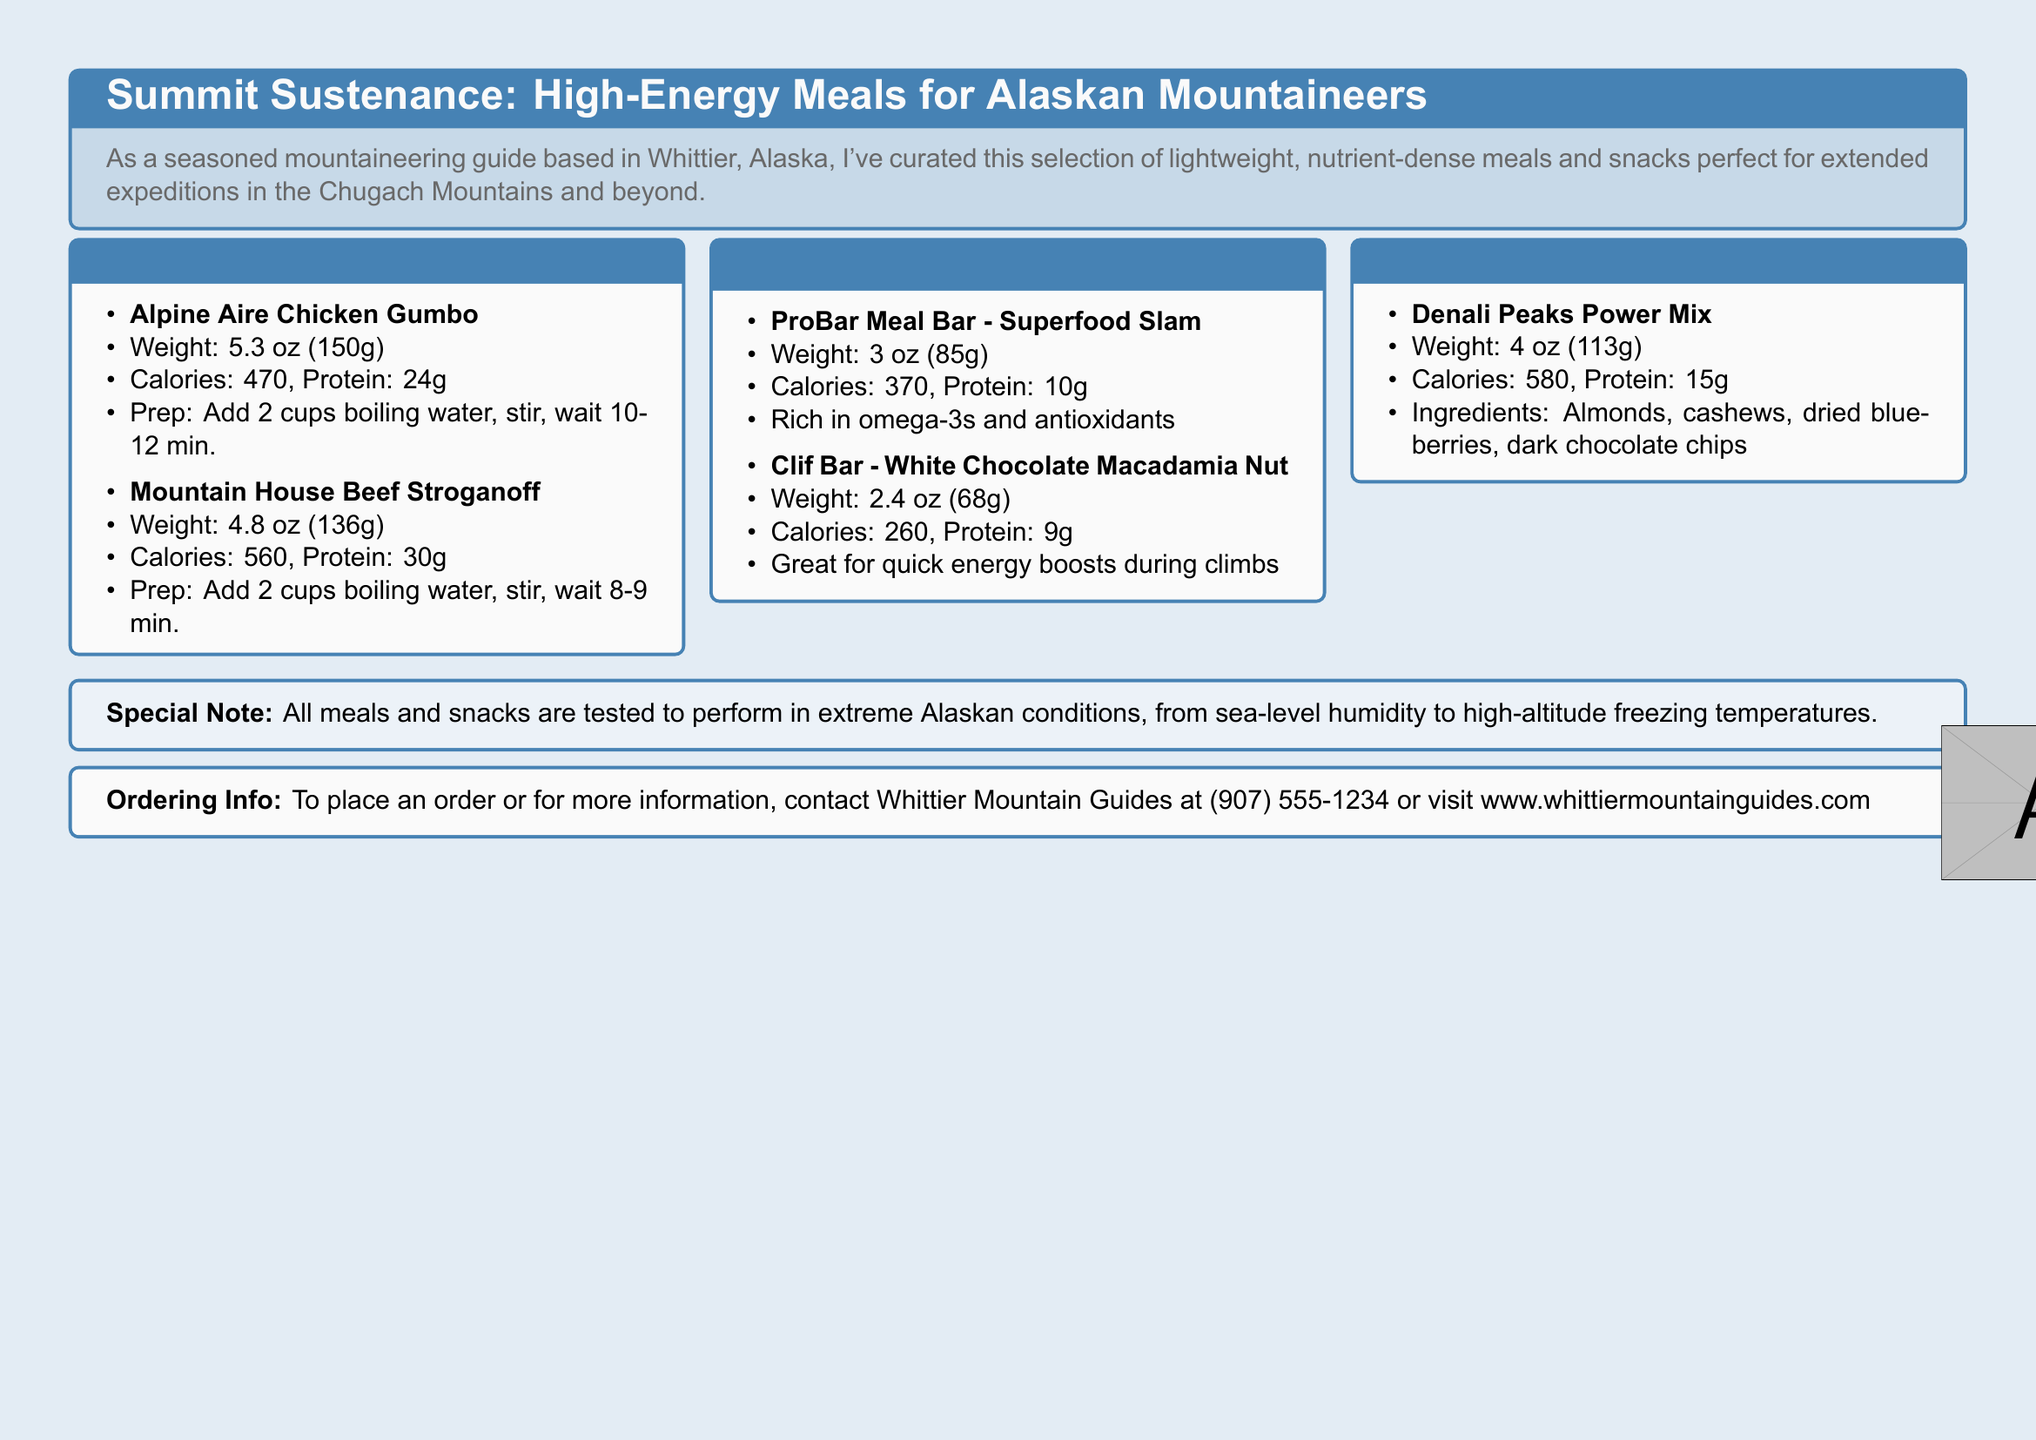what is the weight of Alpine Aire Chicken Gumbo? The weight of Alpine Aire Chicken Gumbo is mentioned in the meal details section of the document.
Answer: 5.3 oz (150g) how many calories does Mountain House Beef Stroganoff provide? The document specifies the calorie content for each meal, including Mountain House Beef Stroganoff.
Answer: 560 which energy bar is rich in omega-3s and antioxidants? The document lists the types of energy bars and their unique features, including nutritional benefits.
Answer: ProBar Meal Bar - Superfood Slam what ingredients are in Denali Peaks Power Mix? The ingredients for Denali Peaks Power Mix are provided in the trail mix section of the document.
Answer: Almonds, cashews, dried blueberries, dark chocolate chips what is the protein content of Clif Bar - White Chocolate Macadamia Nut? The protein content is listed under each energy bar in the catalog.
Answer: 9g how long do you need to wait after adding boiling water to the Alpine Aire Chicken Gumbo? The preparation instructions in the document specify how long to wait after adding boiling water.
Answer: 10-12 min what is the total weight of the energy bars listed? By adding the weight of each listed energy bar in the document, you can calculate the total weight.
Answer: 5.4 oz (153g) what is the recommended contact method for ordering? The document provides specific contact information for placing orders.
Answer: (907) 555-1234 